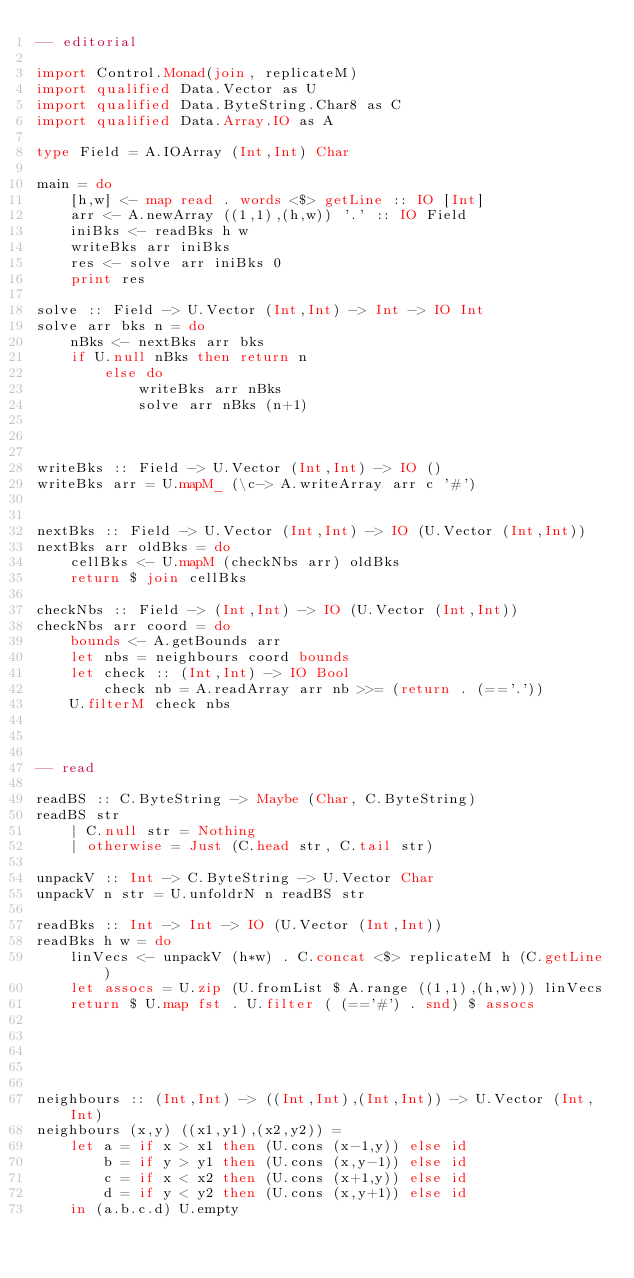<code> <loc_0><loc_0><loc_500><loc_500><_Haskell_>-- editorial

import Control.Monad(join, replicateM)
import qualified Data.Vector as U
import qualified Data.ByteString.Char8 as C
import qualified Data.Array.IO as A

type Field = A.IOArray (Int,Int) Char

main = do
    [h,w] <- map read . words <$> getLine :: IO [Int]
    arr <- A.newArray ((1,1),(h,w)) '.' :: IO Field
    iniBks <- readBks h w
    writeBks arr iniBks
    res <- solve arr iniBks 0
    print res

solve :: Field -> U.Vector (Int,Int) -> Int -> IO Int
solve arr bks n = do
    nBks <- nextBks arr bks
    if U.null nBks then return n
        else do
            writeBks arr nBks
            solve arr nBks (n+1)



writeBks :: Field -> U.Vector (Int,Int) -> IO ()
writeBks arr = U.mapM_ (\c-> A.writeArray arr c '#')


nextBks :: Field -> U.Vector (Int,Int) -> IO (U.Vector (Int,Int))
nextBks arr oldBks = do
    cellBks <- U.mapM (checkNbs arr) oldBks
    return $ join cellBks

checkNbs :: Field -> (Int,Int) -> IO (U.Vector (Int,Int))
checkNbs arr coord = do
    bounds <- A.getBounds arr
    let nbs = neighbours coord bounds
    let check :: (Int,Int) -> IO Bool
        check nb = A.readArray arr nb >>= (return . (=='.'))
    U.filterM check nbs



-- read

readBS :: C.ByteString -> Maybe (Char, C.ByteString)
readBS str
    | C.null str = Nothing
    | otherwise = Just (C.head str, C.tail str)

unpackV :: Int -> C.ByteString -> U.Vector Char
unpackV n str = U.unfoldrN n readBS str

readBks :: Int -> Int -> IO (U.Vector (Int,Int))
readBks h w = do
    linVecs <- unpackV (h*w) . C.concat <$> replicateM h (C.getLine)
    let assocs = U.zip (U.fromList $ A.range ((1,1),(h,w))) linVecs
    return $ U.map fst . U.filter ( (=='#') . snd) $ assocs





neighbours :: (Int,Int) -> ((Int,Int),(Int,Int)) -> U.Vector (Int,Int)
neighbours (x,y) ((x1,y1),(x2,y2)) =
    let a = if x > x1 then (U.cons (x-1,y)) else id
        b = if y > y1 then (U.cons (x,y-1)) else id
        c = if x < x2 then (U.cons (x+1,y)) else id
        d = if y < y2 then (U.cons (x,y+1)) else id
    in (a.b.c.d) U.empty
</code> 